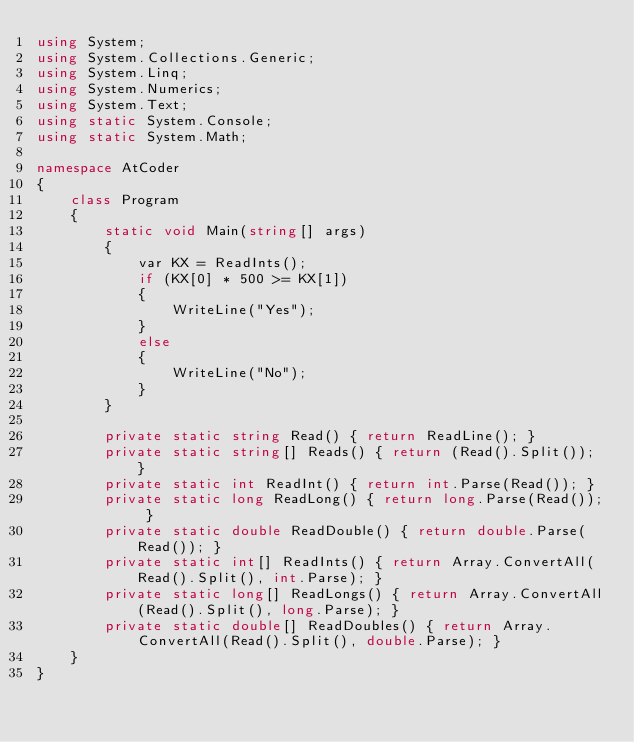<code> <loc_0><loc_0><loc_500><loc_500><_C#_>using System;
using System.Collections.Generic;
using System.Linq;
using System.Numerics;
using System.Text;
using static System.Console;
using static System.Math;

namespace AtCoder
{
    class Program
    {
        static void Main(string[] args)
        {
            var KX = ReadInts();
            if (KX[0] * 500 >= KX[1])
            {
                WriteLine("Yes");
            }
            else
            {
                WriteLine("No");
            }
        }

        private static string Read() { return ReadLine(); }
        private static string[] Reads() { return (Read().Split()); }
        private static int ReadInt() { return int.Parse(Read()); }
        private static long ReadLong() { return long.Parse(Read()); }
        private static double ReadDouble() { return double.Parse(Read()); }
        private static int[] ReadInts() { return Array.ConvertAll(Read().Split(), int.Parse); }
        private static long[] ReadLongs() { return Array.ConvertAll(Read().Split(), long.Parse); }
        private static double[] ReadDoubles() { return Array.ConvertAll(Read().Split(), double.Parse); }
    }
}
</code> 